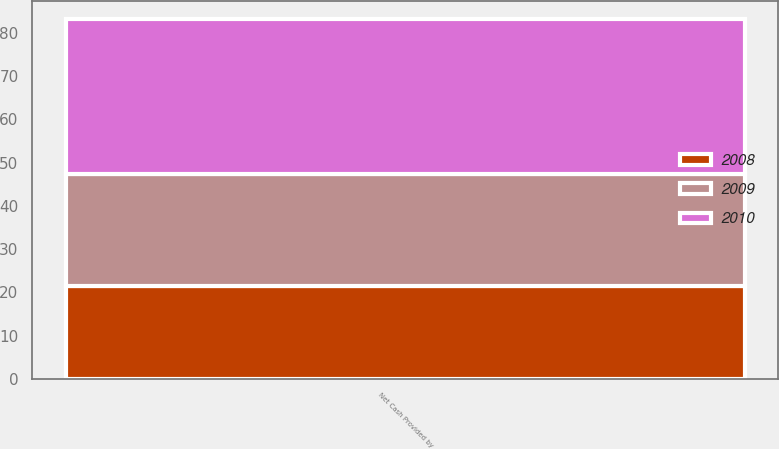Convert chart to OTSL. <chart><loc_0><loc_0><loc_500><loc_500><stacked_bar_chart><ecel><fcel>Net Cash Provided by<nl><fcel>2010<fcel>35.9<nl><fcel>2008<fcel>21.4<nl><fcel>2009<fcel>25.9<nl></chart> 